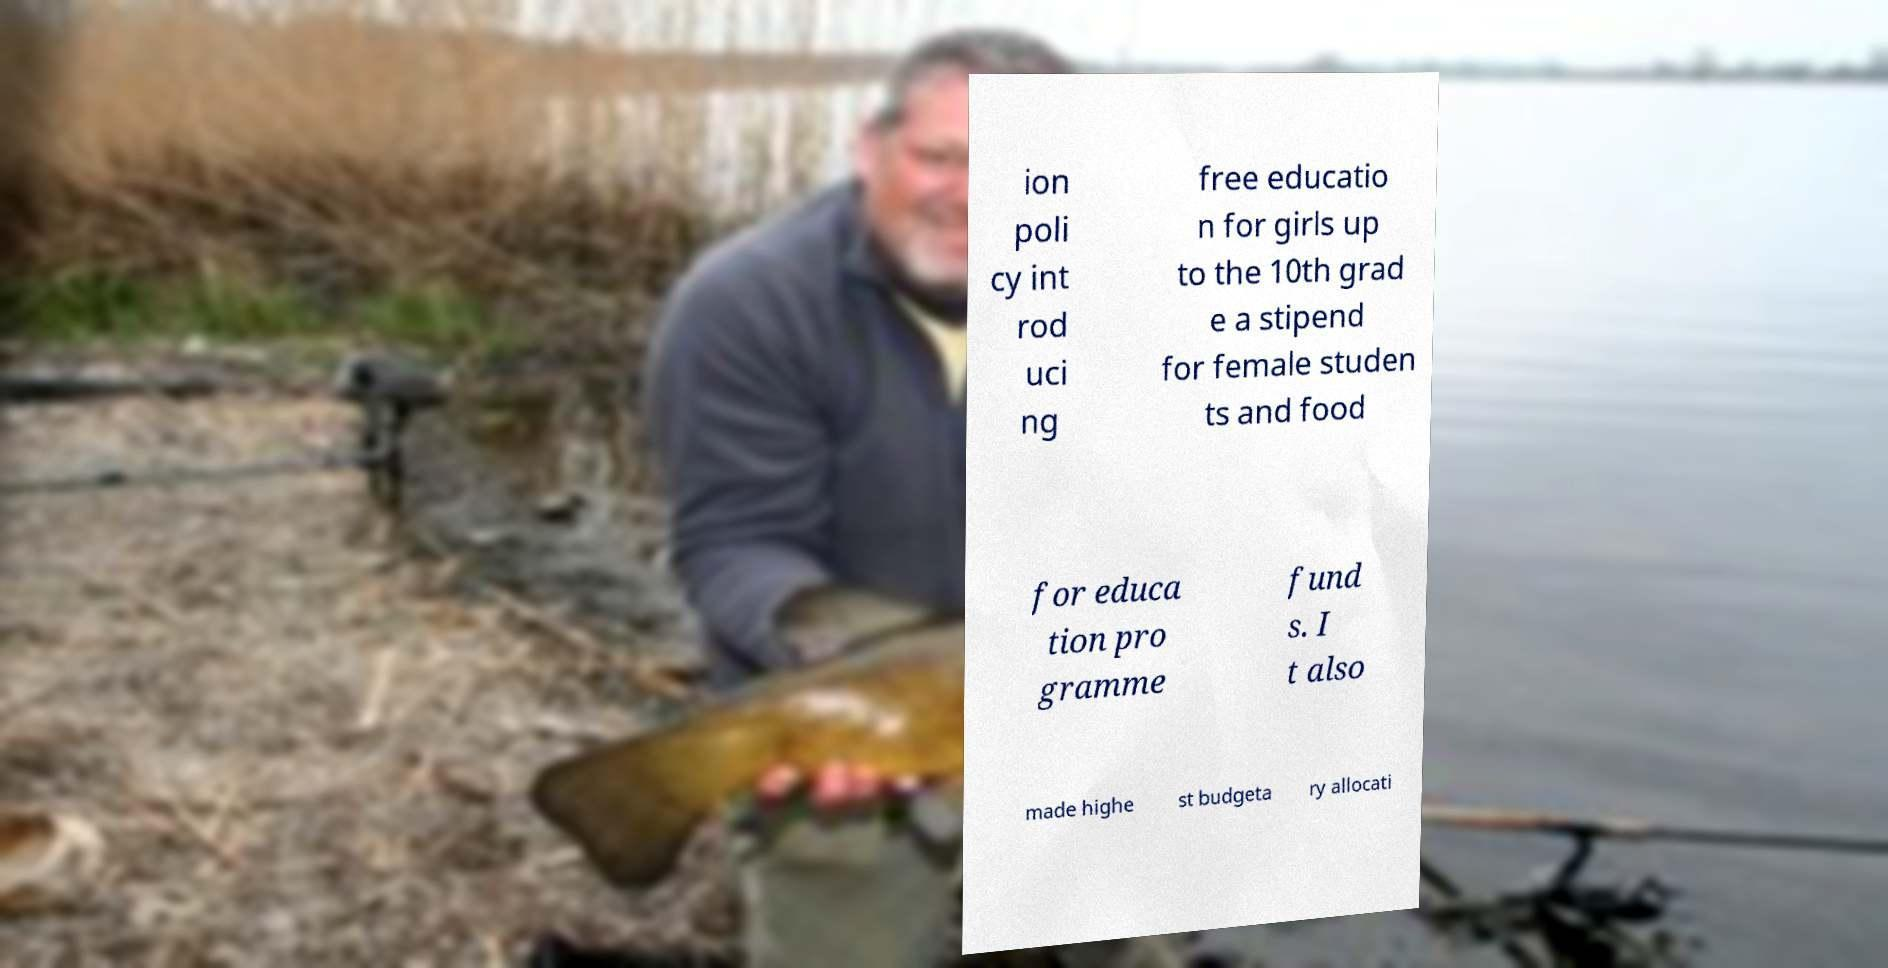Please identify and transcribe the text found in this image. ion poli cy int rod uci ng free educatio n for girls up to the 10th grad e a stipend for female studen ts and food for educa tion pro gramme fund s. I t also made highe st budgeta ry allocati 